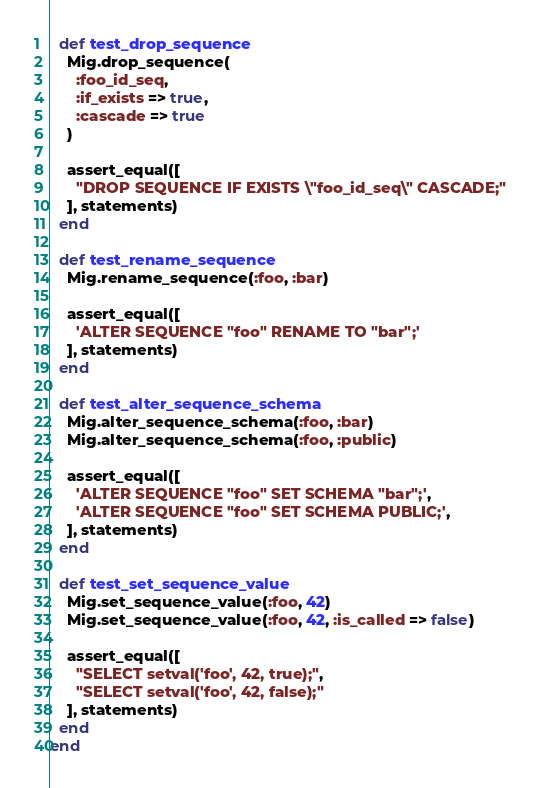Convert code to text. <code><loc_0><loc_0><loc_500><loc_500><_Ruby_>
  def test_drop_sequence
    Mig.drop_sequence(
      :foo_id_seq,
      :if_exists => true,
      :cascade => true
    )

    assert_equal([
      "DROP SEQUENCE IF EXISTS \"foo_id_seq\" CASCADE;"
    ], statements)
  end

  def test_rename_sequence
    Mig.rename_sequence(:foo, :bar)

    assert_equal([
      'ALTER SEQUENCE "foo" RENAME TO "bar";'
    ], statements)
  end

  def test_alter_sequence_schema
    Mig.alter_sequence_schema(:foo, :bar)
    Mig.alter_sequence_schema(:foo, :public)

    assert_equal([
      'ALTER SEQUENCE "foo" SET SCHEMA "bar";',
      'ALTER SEQUENCE "foo" SET SCHEMA PUBLIC;',
    ], statements)
  end

  def test_set_sequence_value
    Mig.set_sequence_value(:foo, 42)
    Mig.set_sequence_value(:foo, 42, :is_called => false)

    assert_equal([
      "SELECT setval('foo', 42, true);",
      "SELECT setval('foo', 42, false);"
    ], statements)
  end
end
</code> 